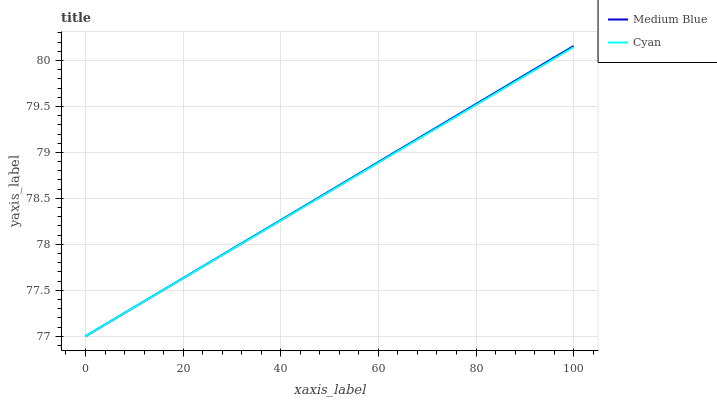Does Medium Blue have the minimum area under the curve?
Answer yes or no. No. Is Medium Blue the roughest?
Answer yes or no. No. 